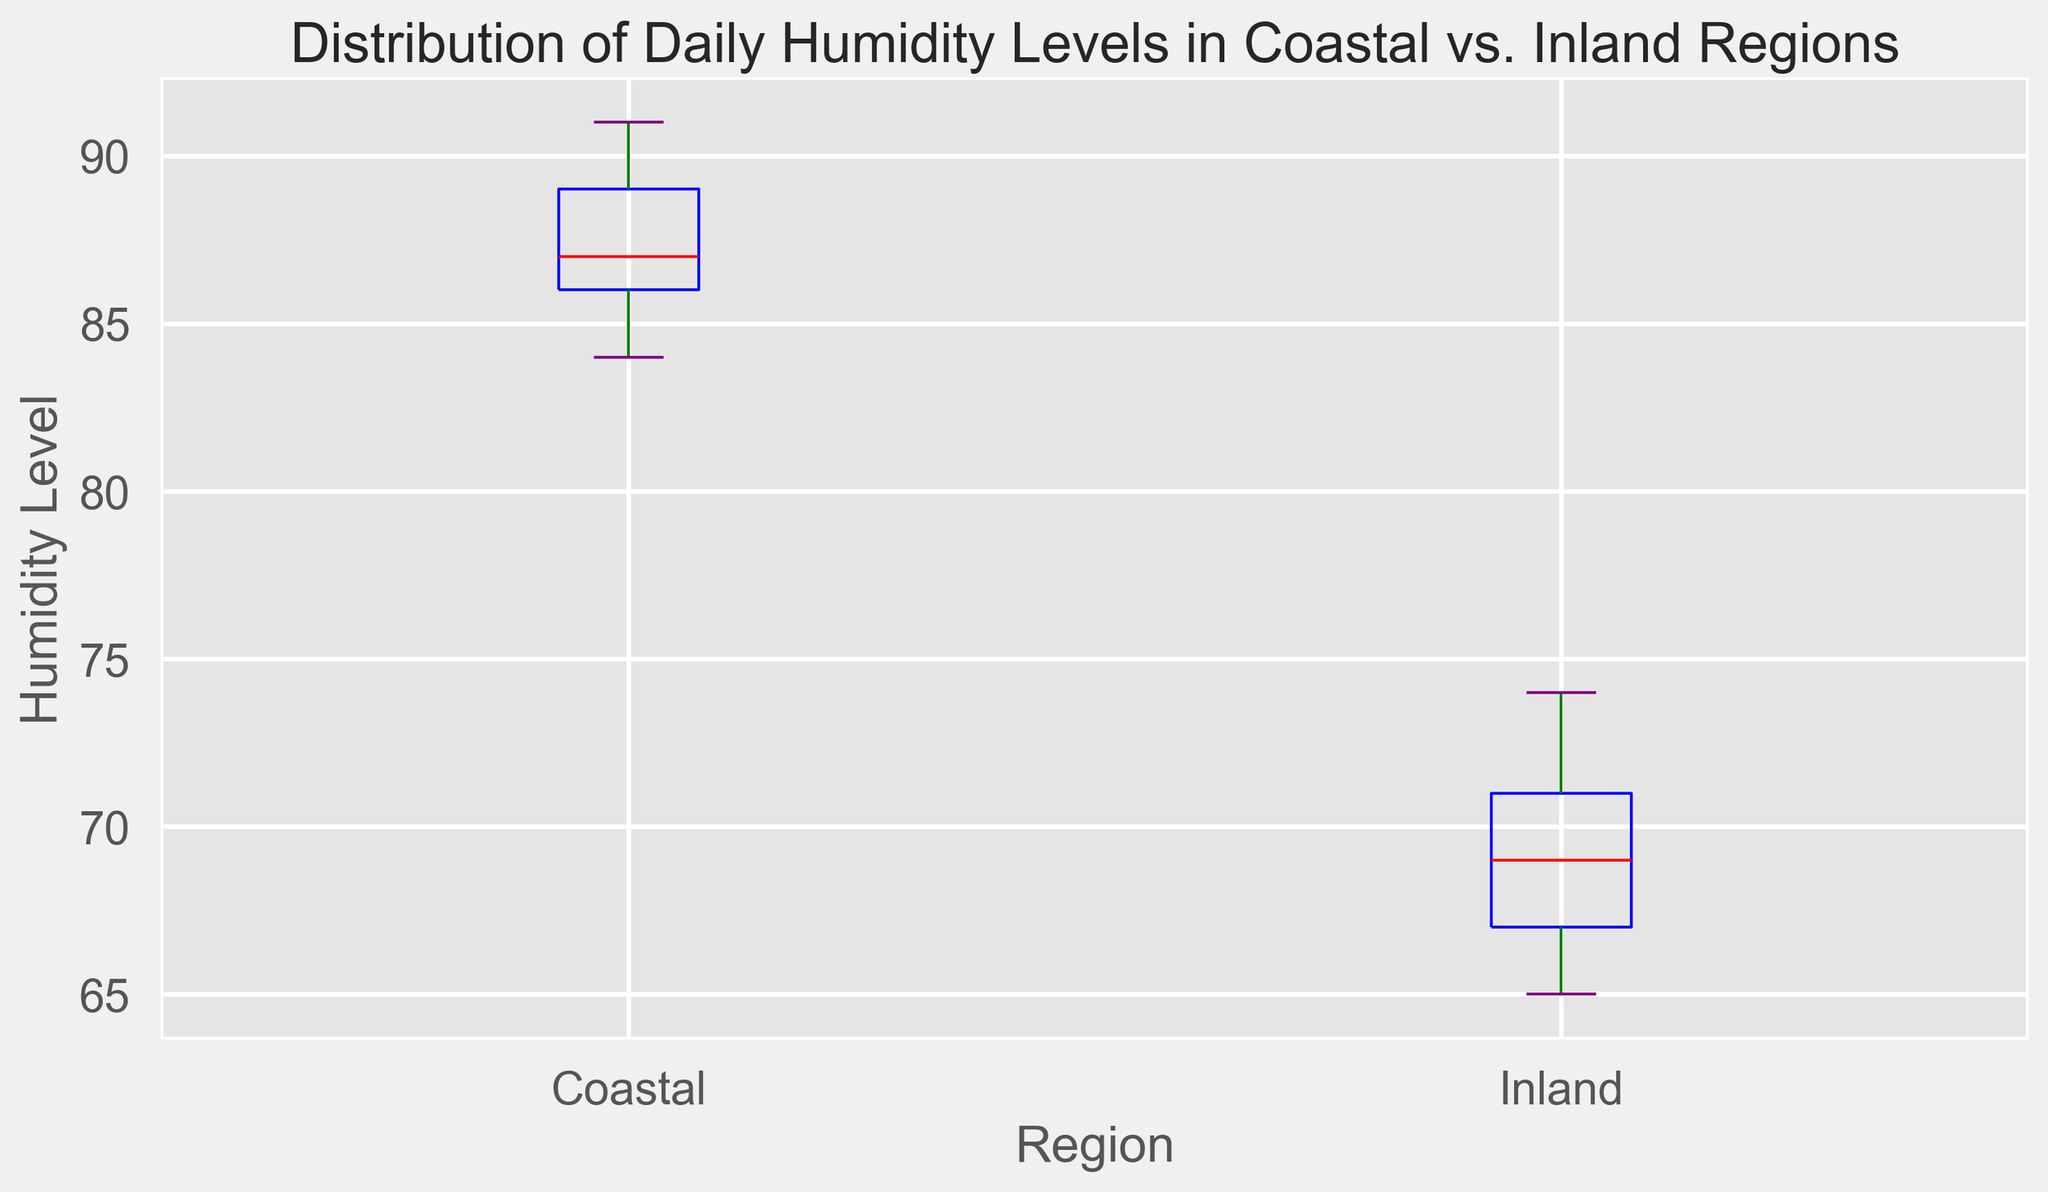What is the median humidity level in the Coastal region? Look for the red median line inside the Coastal boxplot.
Answer: 87 Which region shows a higher variability in daily humidity levels? Compare the interquartile ranges (box lengths) and whiskers in both box plots. The Coastal region has a wider box and longer whiskers compared to the Inland region, indicating higher variability.
Answer: Coastal What is the median difference in humidity levels between the Coastal and Inland regions? The median for Coastal is 87, and for Inland, it is 69. Compute the difference: 87 - 69.
Answer: 18 Which region has the lowest recorded daily humidity level and what is the value? Look at the lower whiskers of both box plots. The Coastal region’s lowest value is 84, and the Inland region’s lowest value is 65. Inland has the lower value.
Answer: Inland, 65 What is the spread of the central 50% of data (interquartile range) in the Inland region? Identify the edges of the box for the Inland region, which are the first and third quartiles (Q1 and Q3). Q1 is around 66, Q3 is around 71. Calculate the difference: 71 - 66.
Answer: 5 Which region has a higher upper quartile (75th percentile)? Check the top edges of both boxes in the box plot. The top edge of the Coastal box is at approximately 89, while the Inland box is at around 71.
Answer: Coastal What are the upper and lower bounds (whiskers) for the Coastal region? Look at the whiskers extending from the box in the Coastal region. The lower whisker is at 84, and the upper whisker is at 91.
Answer: 84 and 91 How many outliers are present in the Inland region? Count the number of flier markers (orange circles) beyond the whiskers in the Inland box plot.
Answer: None In the Coastal region, what is the range of daily humidity levels? Identify the minimum and maximum values from the whiskers in the Coastal box plot. The range is the difference between the highest (91) and the lowest (84) values: 91 - 84.
Answer: 7 